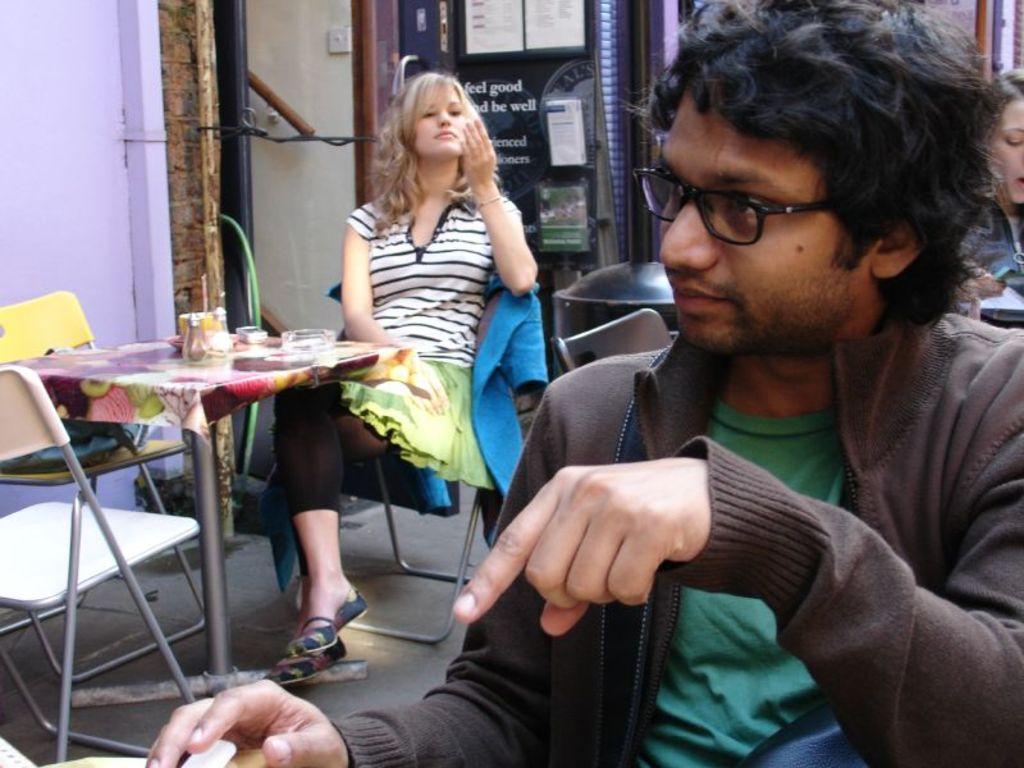Please provide a concise description of this image. Here we can see a man wearing spectacles and a woman sitting on chairs in front of a table and on the table we can see a ash tray and a container. On the background we can see a wall and a machine. 